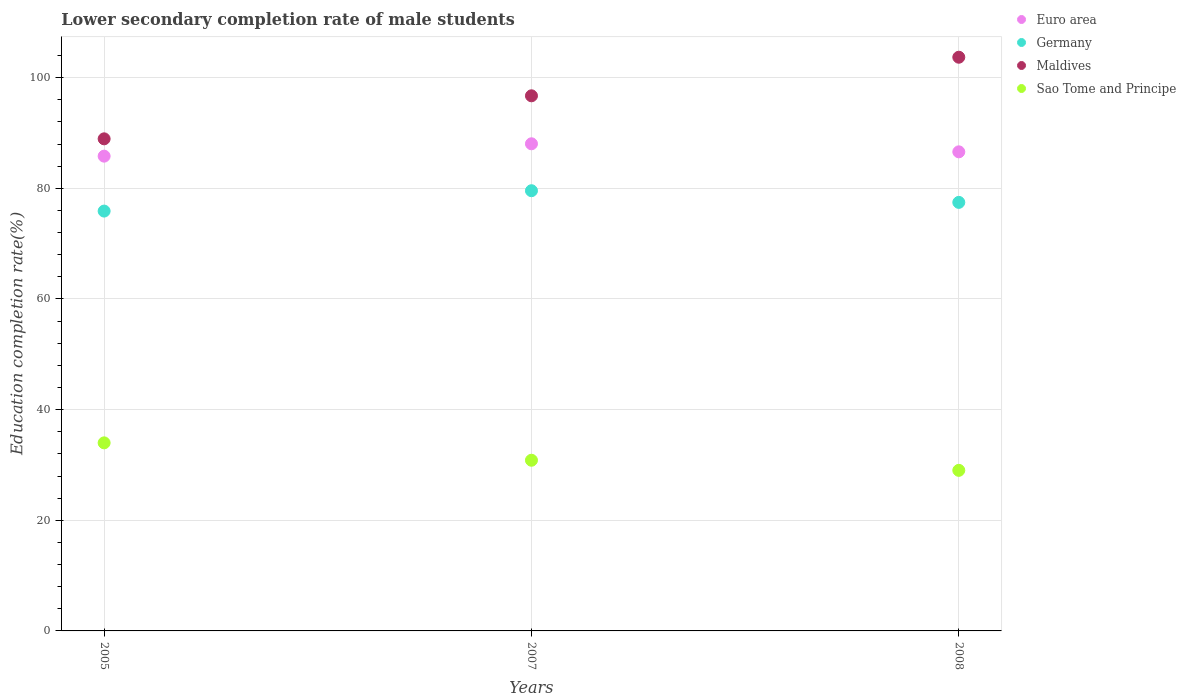How many different coloured dotlines are there?
Your response must be concise. 4. Is the number of dotlines equal to the number of legend labels?
Keep it short and to the point. Yes. What is the lower secondary completion rate of male students in Germany in 2007?
Your response must be concise. 79.57. Across all years, what is the maximum lower secondary completion rate of male students in Sao Tome and Principe?
Your answer should be very brief. 33.99. Across all years, what is the minimum lower secondary completion rate of male students in Euro area?
Provide a succinct answer. 85.82. In which year was the lower secondary completion rate of male students in Maldives maximum?
Give a very brief answer. 2008. In which year was the lower secondary completion rate of male students in Euro area minimum?
Make the answer very short. 2005. What is the total lower secondary completion rate of male students in Germany in the graph?
Your answer should be very brief. 232.93. What is the difference between the lower secondary completion rate of male students in Maldives in 2005 and that in 2007?
Your response must be concise. -7.78. What is the difference between the lower secondary completion rate of male students in Euro area in 2005 and the lower secondary completion rate of male students in Sao Tome and Principe in 2008?
Provide a short and direct response. 56.79. What is the average lower secondary completion rate of male students in Euro area per year?
Your answer should be compact. 86.83. In the year 2007, what is the difference between the lower secondary completion rate of male students in Germany and lower secondary completion rate of male students in Euro area?
Give a very brief answer. -8.48. What is the ratio of the lower secondary completion rate of male students in Germany in 2007 to that in 2008?
Make the answer very short. 1.03. Is the difference between the lower secondary completion rate of male students in Germany in 2007 and 2008 greater than the difference between the lower secondary completion rate of male students in Euro area in 2007 and 2008?
Your response must be concise. Yes. What is the difference between the highest and the second highest lower secondary completion rate of male students in Euro area?
Offer a very short reply. 1.46. What is the difference between the highest and the lowest lower secondary completion rate of male students in Maldives?
Provide a short and direct response. 14.75. Is the sum of the lower secondary completion rate of male students in Euro area in 2005 and 2007 greater than the maximum lower secondary completion rate of male students in Sao Tome and Principe across all years?
Your answer should be very brief. Yes. Is it the case that in every year, the sum of the lower secondary completion rate of male students in Maldives and lower secondary completion rate of male students in Euro area  is greater than the sum of lower secondary completion rate of male students in Germany and lower secondary completion rate of male students in Sao Tome and Principe?
Ensure brevity in your answer.  Yes. Is the lower secondary completion rate of male students in Germany strictly greater than the lower secondary completion rate of male students in Maldives over the years?
Make the answer very short. No. Are the values on the major ticks of Y-axis written in scientific E-notation?
Keep it short and to the point. No. Does the graph contain any zero values?
Your response must be concise. No. Does the graph contain grids?
Offer a terse response. Yes. Where does the legend appear in the graph?
Offer a terse response. Top right. How many legend labels are there?
Provide a short and direct response. 4. What is the title of the graph?
Your answer should be compact. Lower secondary completion rate of male students. Does "Turkey" appear as one of the legend labels in the graph?
Offer a very short reply. No. What is the label or title of the Y-axis?
Ensure brevity in your answer.  Education completion rate(%). What is the Education completion rate(%) of Euro area in 2005?
Your response must be concise. 85.82. What is the Education completion rate(%) of Germany in 2005?
Give a very brief answer. 75.89. What is the Education completion rate(%) of Maldives in 2005?
Your answer should be very brief. 88.95. What is the Education completion rate(%) in Sao Tome and Principe in 2005?
Offer a terse response. 33.99. What is the Education completion rate(%) of Euro area in 2007?
Offer a very short reply. 88.06. What is the Education completion rate(%) in Germany in 2007?
Make the answer very short. 79.57. What is the Education completion rate(%) in Maldives in 2007?
Ensure brevity in your answer.  96.73. What is the Education completion rate(%) in Sao Tome and Principe in 2007?
Give a very brief answer. 30.85. What is the Education completion rate(%) in Euro area in 2008?
Your answer should be very brief. 86.6. What is the Education completion rate(%) of Germany in 2008?
Offer a terse response. 77.46. What is the Education completion rate(%) of Maldives in 2008?
Your answer should be very brief. 103.7. What is the Education completion rate(%) in Sao Tome and Principe in 2008?
Provide a short and direct response. 29.03. Across all years, what is the maximum Education completion rate(%) in Euro area?
Your response must be concise. 88.06. Across all years, what is the maximum Education completion rate(%) of Germany?
Provide a short and direct response. 79.57. Across all years, what is the maximum Education completion rate(%) of Maldives?
Offer a very short reply. 103.7. Across all years, what is the maximum Education completion rate(%) of Sao Tome and Principe?
Offer a very short reply. 33.99. Across all years, what is the minimum Education completion rate(%) of Euro area?
Provide a succinct answer. 85.82. Across all years, what is the minimum Education completion rate(%) of Germany?
Keep it short and to the point. 75.89. Across all years, what is the minimum Education completion rate(%) in Maldives?
Keep it short and to the point. 88.95. Across all years, what is the minimum Education completion rate(%) of Sao Tome and Principe?
Ensure brevity in your answer.  29.03. What is the total Education completion rate(%) in Euro area in the graph?
Your answer should be very brief. 260.48. What is the total Education completion rate(%) of Germany in the graph?
Your response must be concise. 232.93. What is the total Education completion rate(%) of Maldives in the graph?
Your answer should be very brief. 289.38. What is the total Education completion rate(%) of Sao Tome and Principe in the graph?
Offer a terse response. 93.87. What is the difference between the Education completion rate(%) in Euro area in 2005 and that in 2007?
Your response must be concise. -2.24. What is the difference between the Education completion rate(%) in Germany in 2005 and that in 2007?
Make the answer very short. -3.68. What is the difference between the Education completion rate(%) in Maldives in 2005 and that in 2007?
Keep it short and to the point. -7.78. What is the difference between the Education completion rate(%) in Sao Tome and Principe in 2005 and that in 2007?
Your answer should be compact. 3.14. What is the difference between the Education completion rate(%) in Euro area in 2005 and that in 2008?
Provide a short and direct response. -0.78. What is the difference between the Education completion rate(%) of Germany in 2005 and that in 2008?
Provide a succinct answer. -1.57. What is the difference between the Education completion rate(%) in Maldives in 2005 and that in 2008?
Ensure brevity in your answer.  -14.75. What is the difference between the Education completion rate(%) in Sao Tome and Principe in 2005 and that in 2008?
Ensure brevity in your answer.  4.97. What is the difference between the Education completion rate(%) of Euro area in 2007 and that in 2008?
Your response must be concise. 1.46. What is the difference between the Education completion rate(%) of Germany in 2007 and that in 2008?
Offer a very short reply. 2.11. What is the difference between the Education completion rate(%) in Maldives in 2007 and that in 2008?
Ensure brevity in your answer.  -6.97. What is the difference between the Education completion rate(%) in Sao Tome and Principe in 2007 and that in 2008?
Your response must be concise. 1.83. What is the difference between the Education completion rate(%) in Euro area in 2005 and the Education completion rate(%) in Germany in 2007?
Your answer should be compact. 6.25. What is the difference between the Education completion rate(%) in Euro area in 2005 and the Education completion rate(%) in Maldives in 2007?
Your answer should be very brief. -10.91. What is the difference between the Education completion rate(%) in Euro area in 2005 and the Education completion rate(%) in Sao Tome and Principe in 2007?
Your answer should be very brief. 54.97. What is the difference between the Education completion rate(%) in Germany in 2005 and the Education completion rate(%) in Maldives in 2007?
Give a very brief answer. -20.84. What is the difference between the Education completion rate(%) of Germany in 2005 and the Education completion rate(%) of Sao Tome and Principe in 2007?
Your answer should be very brief. 45.04. What is the difference between the Education completion rate(%) of Maldives in 2005 and the Education completion rate(%) of Sao Tome and Principe in 2007?
Ensure brevity in your answer.  58.1. What is the difference between the Education completion rate(%) in Euro area in 2005 and the Education completion rate(%) in Germany in 2008?
Ensure brevity in your answer.  8.36. What is the difference between the Education completion rate(%) in Euro area in 2005 and the Education completion rate(%) in Maldives in 2008?
Offer a very short reply. -17.88. What is the difference between the Education completion rate(%) of Euro area in 2005 and the Education completion rate(%) of Sao Tome and Principe in 2008?
Your answer should be very brief. 56.79. What is the difference between the Education completion rate(%) of Germany in 2005 and the Education completion rate(%) of Maldives in 2008?
Offer a very short reply. -27.81. What is the difference between the Education completion rate(%) of Germany in 2005 and the Education completion rate(%) of Sao Tome and Principe in 2008?
Make the answer very short. 46.87. What is the difference between the Education completion rate(%) in Maldives in 2005 and the Education completion rate(%) in Sao Tome and Principe in 2008?
Make the answer very short. 59.93. What is the difference between the Education completion rate(%) of Euro area in 2007 and the Education completion rate(%) of Germany in 2008?
Offer a terse response. 10.59. What is the difference between the Education completion rate(%) in Euro area in 2007 and the Education completion rate(%) in Maldives in 2008?
Offer a terse response. -15.65. What is the difference between the Education completion rate(%) in Euro area in 2007 and the Education completion rate(%) in Sao Tome and Principe in 2008?
Your answer should be very brief. 59.03. What is the difference between the Education completion rate(%) in Germany in 2007 and the Education completion rate(%) in Maldives in 2008?
Give a very brief answer. -24.13. What is the difference between the Education completion rate(%) in Germany in 2007 and the Education completion rate(%) in Sao Tome and Principe in 2008?
Ensure brevity in your answer.  50.55. What is the difference between the Education completion rate(%) in Maldives in 2007 and the Education completion rate(%) in Sao Tome and Principe in 2008?
Offer a very short reply. 67.7. What is the average Education completion rate(%) in Euro area per year?
Your response must be concise. 86.83. What is the average Education completion rate(%) in Germany per year?
Provide a succinct answer. 77.64. What is the average Education completion rate(%) of Maldives per year?
Offer a terse response. 96.46. What is the average Education completion rate(%) of Sao Tome and Principe per year?
Offer a terse response. 31.29. In the year 2005, what is the difference between the Education completion rate(%) of Euro area and Education completion rate(%) of Germany?
Offer a very short reply. 9.93. In the year 2005, what is the difference between the Education completion rate(%) of Euro area and Education completion rate(%) of Maldives?
Offer a terse response. -3.13. In the year 2005, what is the difference between the Education completion rate(%) of Euro area and Education completion rate(%) of Sao Tome and Principe?
Keep it short and to the point. 51.83. In the year 2005, what is the difference between the Education completion rate(%) of Germany and Education completion rate(%) of Maldives?
Provide a short and direct response. -13.06. In the year 2005, what is the difference between the Education completion rate(%) in Germany and Education completion rate(%) in Sao Tome and Principe?
Your answer should be very brief. 41.9. In the year 2005, what is the difference between the Education completion rate(%) in Maldives and Education completion rate(%) in Sao Tome and Principe?
Your answer should be very brief. 54.96. In the year 2007, what is the difference between the Education completion rate(%) of Euro area and Education completion rate(%) of Germany?
Give a very brief answer. 8.48. In the year 2007, what is the difference between the Education completion rate(%) in Euro area and Education completion rate(%) in Maldives?
Provide a succinct answer. -8.67. In the year 2007, what is the difference between the Education completion rate(%) of Euro area and Education completion rate(%) of Sao Tome and Principe?
Make the answer very short. 57.2. In the year 2007, what is the difference between the Education completion rate(%) of Germany and Education completion rate(%) of Maldives?
Provide a short and direct response. -17.16. In the year 2007, what is the difference between the Education completion rate(%) of Germany and Education completion rate(%) of Sao Tome and Principe?
Make the answer very short. 48.72. In the year 2007, what is the difference between the Education completion rate(%) of Maldives and Education completion rate(%) of Sao Tome and Principe?
Your response must be concise. 65.88. In the year 2008, what is the difference between the Education completion rate(%) in Euro area and Education completion rate(%) in Germany?
Ensure brevity in your answer.  9.14. In the year 2008, what is the difference between the Education completion rate(%) of Euro area and Education completion rate(%) of Maldives?
Your answer should be compact. -17.1. In the year 2008, what is the difference between the Education completion rate(%) of Euro area and Education completion rate(%) of Sao Tome and Principe?
Give a very brief answer. 57.58. In the year 2008, what is the difference between the Education completion rate(%) in Germany and Education completion rate(%) in Maldives?
Provide a short and direct response. -26.24. In the year 2008, what is the difference between the Education completion rate(%) of Germany and Education completion rate(%) of Sao Tome and Principe?
Make the answer very short. 48.44. In the year 2008, what is the difference between the Education completion rate(%) in Maldives and Education completion rate(%) in Sao Tome and Principe?
Give a very brief answer. 74.68. What is the ratio of the Education completion rate(%) in Euro area in 2005 to that in 2007?
Provide a short and direct response. 0.97. What is the ratio of the Education completion rate(%) of Germany in 2005 to that in 2007?
Your answer should be compact. 0.95. What is the ratio of the Education completion rate(%) of Maldives in 2005 to that in 2007?
Make the answer very short. 0.92. What is the ratio of the Education completion rate(%) of Sao Tome and Principe in 2005 to that in 2007?
Your answer should be very brief. 1.1. What is the ratio of the Education completion rate(%) of Euro area in 2005 to that in 2008?
Your response must be concise. 0.99. What is the ratio of the Education completion rate(%) of Germany in 2005 to that in 2008?
Provide a succinct answer. 0.98. What is the ratio of the Education completion rate(%) of Maldives in 2005 to that in 2008?
Offer a terse response. 0.86. What is the ratio of the Education completion rate(%) of Sao Tome and Principe in 2005 to that in 2008?
Give a very brief answer. 1.17. What is the ratio of the Education completion rate(%) in Euro area in 2007 to that in 2008?
Give a very brief answer. 1.02. What is the ratio of the Education completion rate(%) in Germany in 2007 to that in 2008?
Keep it short and to the point. 1.03. What is the ratio of the Education completion rate(%) in Maldives in 2007 to that in 2008?
Make the answer very short. 0.93. What is the ratio of the Education completion rate(%) of Sao Tome and Principe in 2007 to that in 2008?
Provide a short and direct response. 1.06. What is the difference between the highest and the second highest Education completion rate(%) of Euro area?
Give a very brief answer. 1.46. What is the difference between the highest and the second highest Education completion rate(%) in Germany?
Make the answer very short. 2.11. What is the difference between the highest and the second highest Education completion rate(%) in Maldives?
Keep it short and to the point. 6.97. What is the difference between the highest and the second highest Education completion rate(%) of Sao Tome and Principe?
Provide a succinct answer. 3.14. What is the difference between the highest and the lowest Education completion rate(%) of Euro area?
Provide a succinct answer. 2.24. What is the difference between the highest and the lowest Education completion rate(%) of Germany?
Offer a very short reply. 3.68. What is the difference between the highest and the lowest Education completion rate(%) in Maldives?
Your answer should be compact. 14.75. What is the difference between the highest and the lowest Education completion rate(%) of Sao Tome and Principe?
Keep it short and to the point. 4.97. 